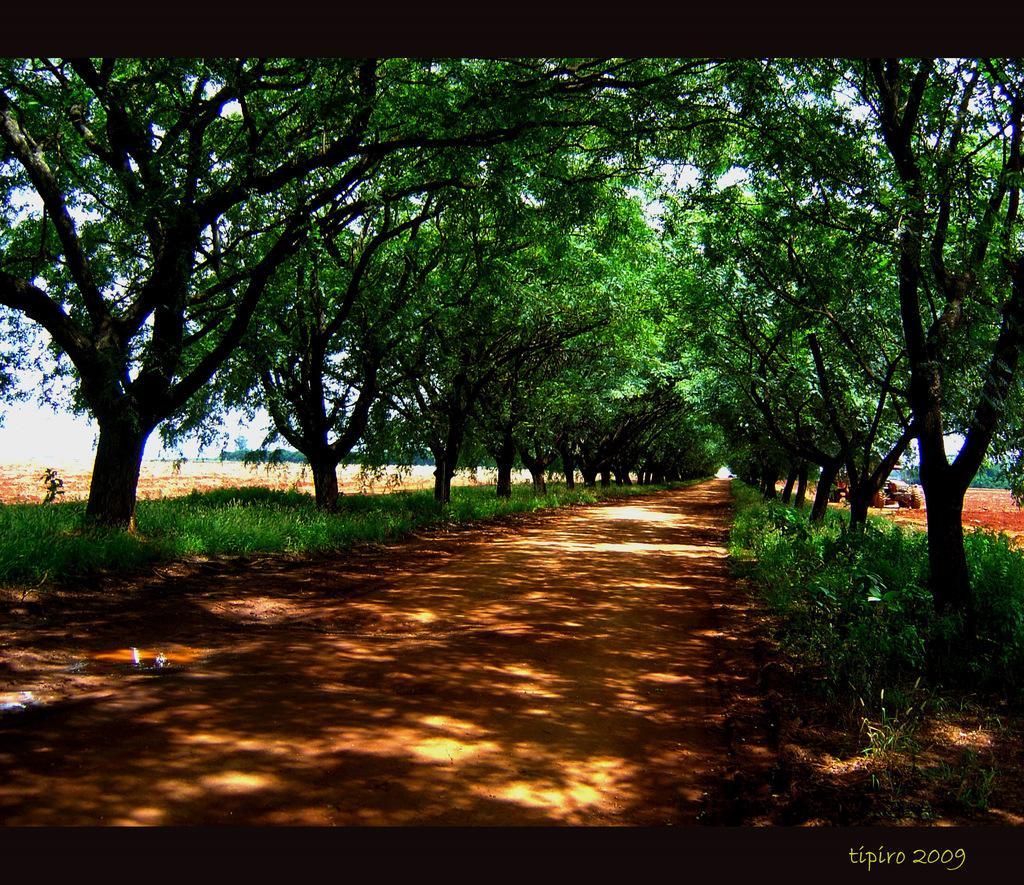What is located at the bottom of the image? There is a path at the bottom of the image. What type of vegetation can be seen on both sides of the path? Grass is present on both sides of the path. What else can be seen on both sides of the path? Trees are visible on both sides of the path. Where is the text located in the image? The text is in the bottom right-hand corner of the image. What type of cannon is located in the center of the circle in the image? There is no cannon or circle present in the image. 